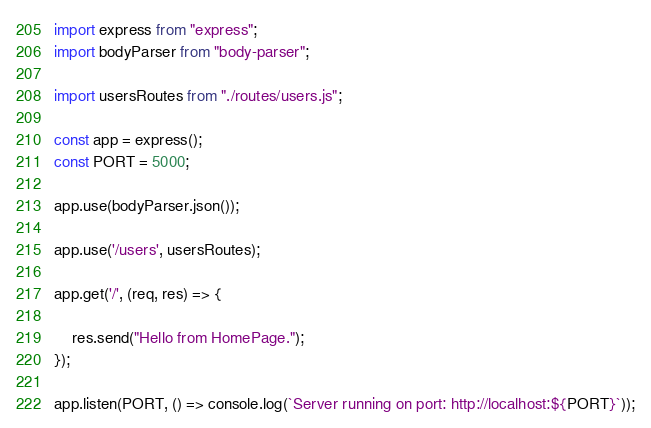<code> <loc_0><loc_0><loc_500><loc_500><_JavaScript_>import express from "express";
import bodyParser from "body-parser";

import usersRoutes from "./routes/users.js";

const app = express();
const PORT = 5000;

app.use(bodyParser.json());

app.use('/users', usersRoutes);

app.get('/', (req, res) => {

    res.send("Hello from HomePage.");
});

app.listen(PORT, () => console.log(`Server running on port: http://localhost:${PORT}`));</code> 